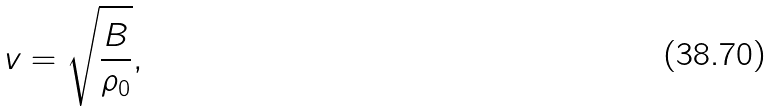<formula> <loc_0><loc_0><loc_500><loc_500>v = { \sqrt { \frac { B } { \rho _ { 0 } } } } ,</formula> 